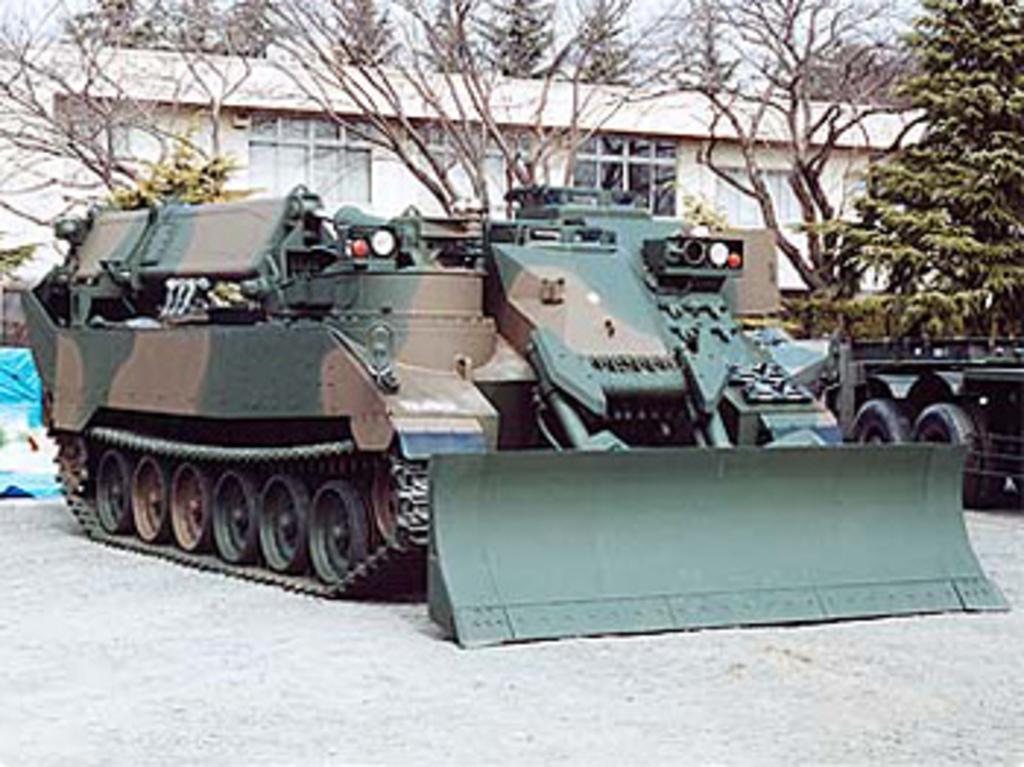Could you give a brief overview of what you see in this image? In this picture I can see there is a military tank and there is a truck onto right side. There are trees in the backdrop and there is building with windows and the sky is clear and there is soil on the floor. 